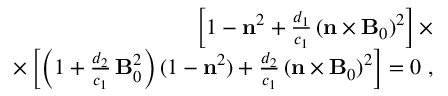<formula> <loc_0><loc_0><loc_500><loc_500>\begin{array} { r } { \left [ 1 - { n } ^ { 2 } + \frac { d _ { 1 } } { c _ { 1 } } \, ( { n } \times { B } _ { 0 } ) ^ { 2 } \right ] \times } \\ { \times \left [ \left ( 1 + \frac { d _ { 2 } } { c _ { 1 } } \, { B } _ { 0 } ^ { 2 } \right ) ( 1 - { n } ^ { 2 } ) + \frac { d _ { 2 } } { c _ { 1 } } \, ( { n } \times { B } _ { 0 } ) ^ { 2 } \right ] = 0 \, , } \end{array}</formula> 